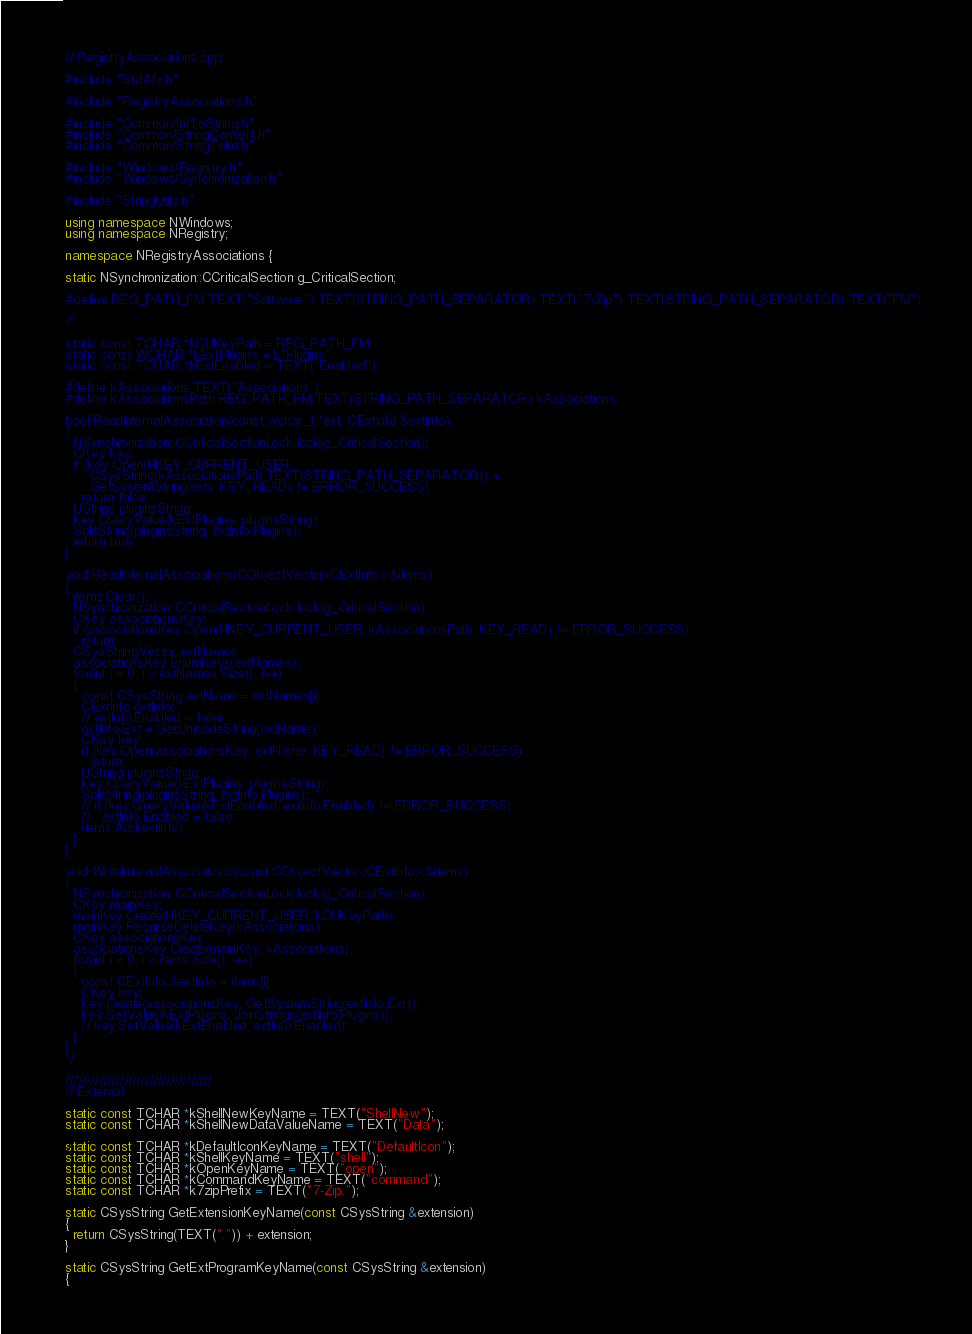Convert code to text. <code><loc_0><loc_0><loc_500><loc_500><_C++_>// RegistryAssociations.cpp

#include "StdAfx.h"

#include "RegistryAssociations.h"

#include "Common/IntToString.h"
#include "Common/StringConvert.h"
#include "Common/StringToInt.h"

#include "Windows/Registry.h"
#include "Windows/Synchronization.h"

#include "StringUtils.h"

using namespace NWindows;
using namespace NRegistry;

namespace NRegistryAssociations {
  
static NSynchronization::CCriticalSection g_CriticalSection;

#define REG_PATH_FM TEXT("Software") TEXT(STRING_PATH_SEPARATOR) TEXT("7-Zip") TEXT(STRING_PATH_SEPARATOR) TEXT("FM")

/*

static const TCHAR *kCUKeyPath = REG_PATH_FM;
static const WCHAR *kExtPlugins = L"Plugins";
static const TCHAR *kExtEnabled = TEXT("Enabled");

#define kAssociations TEXT("Associations")
#define kAssociationsPath REG_PATH_FM TEXT(STRING_PATH_SEPARATOR) kAssociations

bool ReadInternalAssociation(const wchar_t *ext, CExtInfo &extInfo)
{
  NSynchronization::CCriticalSectionLock lock(g_CriticalSection);
  CKey key;
  if (key.Open(HKEY_CURRENT_USER,
      CSysString(kAssociationsPath TEXT(STRING_PATH_SEPARATOR)) +
      GetSystemString(ext), KEY_READ) != ERROR_SUCCESS)
    return false;
  UString pluginsString;
  key.QueryValue(kExtPlugins, pluginsString);
  SplitString(pluginsString, extInfo.Plugins);
  return true;
}

void ReadInternalAssociations(CObjectVector<CExtInfo> &items)
{
  items.Clear();
  NSynchronization::CCriticalSectionLock lock(g_CriticalSection);
  CKey associationsKey;
  if (associationsKey.Open(HKEY_CURRENT_USER, kAssociationsPath, KEY_READ) != ERROR_SUCCESS)
    return;
  CSysStringVector extNames;
  associationsKey.EnumKeys(extNames);
  for(int i = 0; i < extNames.Size(); i++)
  {
    const CSysString extName = extNames[i];
    CExtInfo extInfo;
    // extInfo.Enabled = false;
    extInfo.Ext = GetUnicodeString(extName);
    CKey key;
    if (key.Open(associationsKey, extName, KEY_READ) != ERROR_SUCCESS)
      return;
    UString pluginsString;
    key.QueryValue(kExtPlugins, pluginsString);
    SplitString(pluginsString, extInfo.Plugins);
    // if (key.QueryValue(kExtEnabled, extInfo.Enabled) != ERROR_SUCCESS)
    //   extInfo.Enabled = false;
    items.Add(extInfo);
  }
}

void WriteInternalAssociations(const CObjectVector<CExtInfo> &items)
{
  NSynchronization::CCriticalSectionLock lock(g_CriticalSection);
  CKey mainKey;
  mainKey.Create(HKEY_CURRENT_USER, kCUKeyPath);
  mainKey.RecurseDeleteKey(kAssociations);
  CKey associationsKey;
  associationsKey.Create(mainKey, kAssociations);
  for(int i = 0; i < items.Size(); i++)
  {
    const CExtInfo &extInfo = items[i];
    CKey key;
    key.Create(associationsKey, GetSystemString(extInfo.Ext));
    key.SetValue(kExtPlugins, JoinStrings(extInfo.Plugins));
    // key.SetValue(kExtEnabled, extInfo.Enabled);
  }
}
*/

///////////////////////////////////
// External

static const TCHAR *kShellNewKeyName = TEXT("ShellNew");
static const TCHAR *kShellNewDataValueName = TEXT("Data");
  
static const TCHAR *kDefaultIconKeyName = TEXT("DefaultIcon");
static const TCHAR *kShellKeyName = TEXT("shell");
static const TCHAR *kOpenKeyName = TEXT("open");
static const TCHAR *kCommandKeyName = TEXT("command");
static const TCHAR *k7zipPrefix = TEXT("7-Zip.");

static CSysString GetExtensionKeyName(const CSysString &extension)
{
  return CSysString(TEXT(".")) + extension;
}

static CSysString GetExtProgramKeyName(const CSysString &extension)
{</code> 